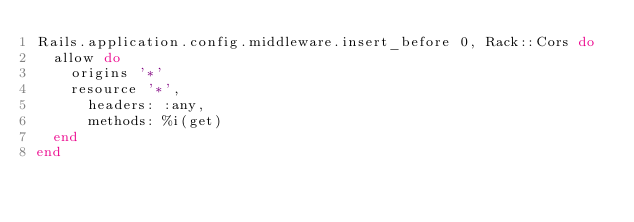Convert code to text. <code><loc_0><loc_0><loc_500><loc_500><_Ruby_>Rails.application.config.middleware.insert_before 0, Rack::Cors do
  allow do
    origins '*'
    resource '*',
      headers: :any,
      methods: %i(get)
  end
end
</code> 